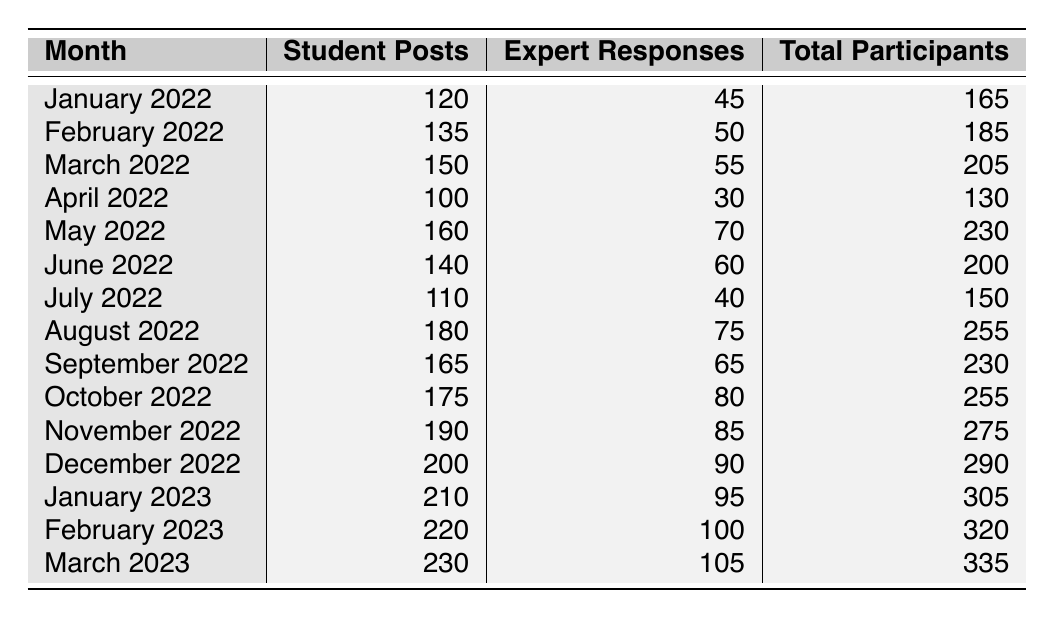What was the total number of student posts in February 2023? In the table, I locate February 2023 and see the value for student posts listed as 220.
Answer: 220 What month had the highest number of total participants? By scanning the total participants column, I find that March 2023 has the highest value at 335.
Answer: March 2023 How many expert responses were there in August 2022? I refer to the table for August 2022 and find the number of expert responses is 75.
Answer: 75 What is the difference in total participants between January 2022 and December 2022? The total participants for January 2022 is 165 and for December 2022 is 290. So, the difference is 290 - 165 = 125.
Answer: 125 What was the average number of student posts from January 2022 to March 2023? I calculate the average by summing the student posts: (120 + 135 + 150 + 100 + 160 + 140 + 110 + 180 + 165 + 175 + 190 + 200 + 210 + 220 + 230) = 2200. There are 15 months, so the average is 2200 / 15 = 146.67.
Answer: 146.67 Did the number of expert responses increase every month from January 2022 to March 2023? I check the expert responses for each month and find that April 2022 has 30 expert responses, which is lower than March 2022 (55), indicating there was a decrease.
Answer: No In which month did the highest number of student posts occur? I review the student posts across all months and see that March 2023 has the highest value at 230.
Answer: March 2023 What is the total number of expert responses from January 2022 to March 2023? By summing the expert responses: (45 + 50 + 55 + 30 + 70 + 60 + 40 + 75 + 65 + 80 + 85 + 90 + 95 + 100 + 105) = 1080.
Answer: 1080 How many total participants were there in July 2022? In the table, July 2022 shows a total of 150 participants.
Answer: 150 What percentage increase in total participants occurred from April 2022 to May 2022? The total participants in April 2022 is 130 and in May 2022 is 230. The increase is 230 - 130 = 100. To find the percentage increase, I calculate (100 / 130) * 100 = 76.92%.
Answer: 76.92% 